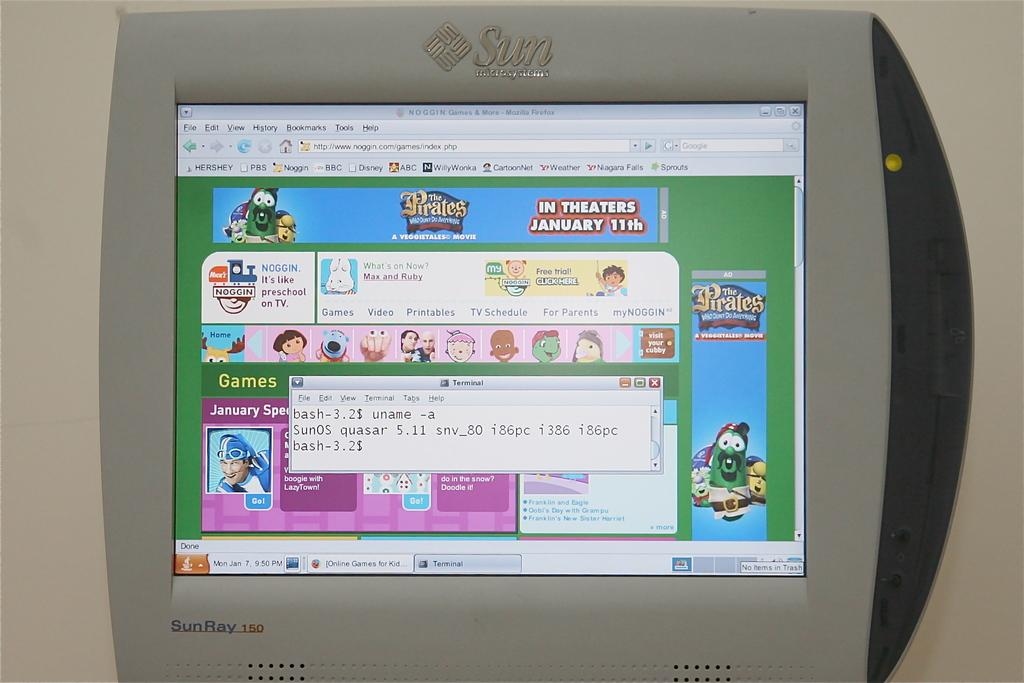Provide a one-sentence caption for the provided image. On a Sun monitor a website advertisement is for The Pirates, in theaters January 11th. 